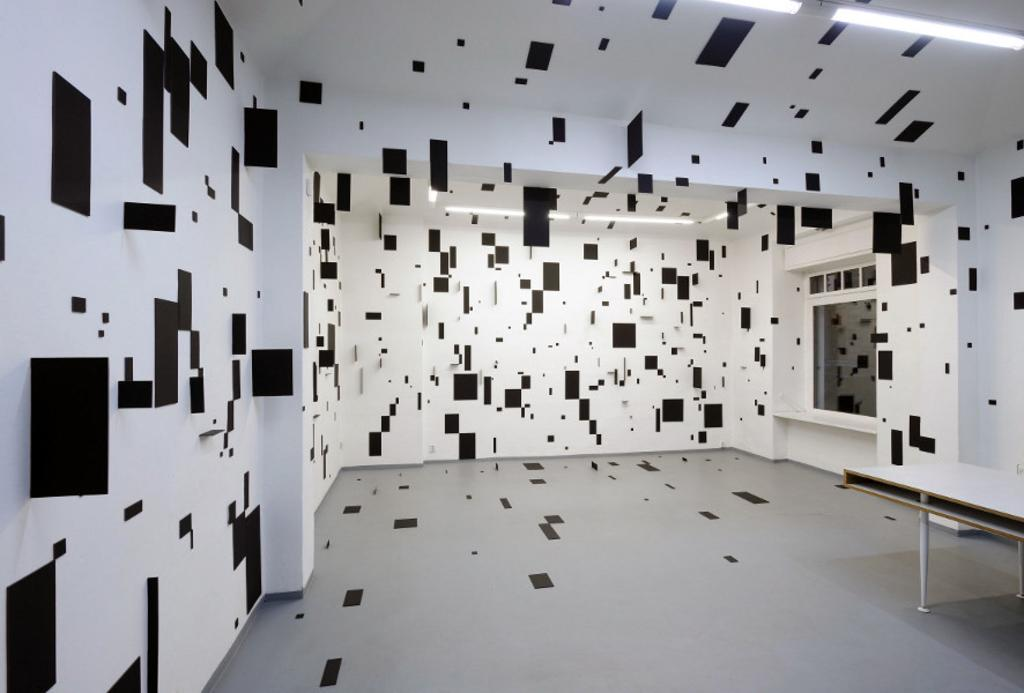What type of space is depicted in the image? The image is of a room. Are there any light sources in the room? Yes, there are lights in the room. What piece of furniture can be seen in the room? There is a table in the room. What is the color and purpose of the papers attached to the wall and floor? The papers are black in color and are for cards. They are attached to the wall and floor. How are the papers for cards arranged in the image? The papers for cards are arranged in a design. What type of jeans is the person wearing in the image? There is no person visible in the image, and therefore no clothing can be observed. How much ink is needed to fill the rain puddles in the image? There are no rain puddles present in the image, so the amount of ink needed cannot be determined. 